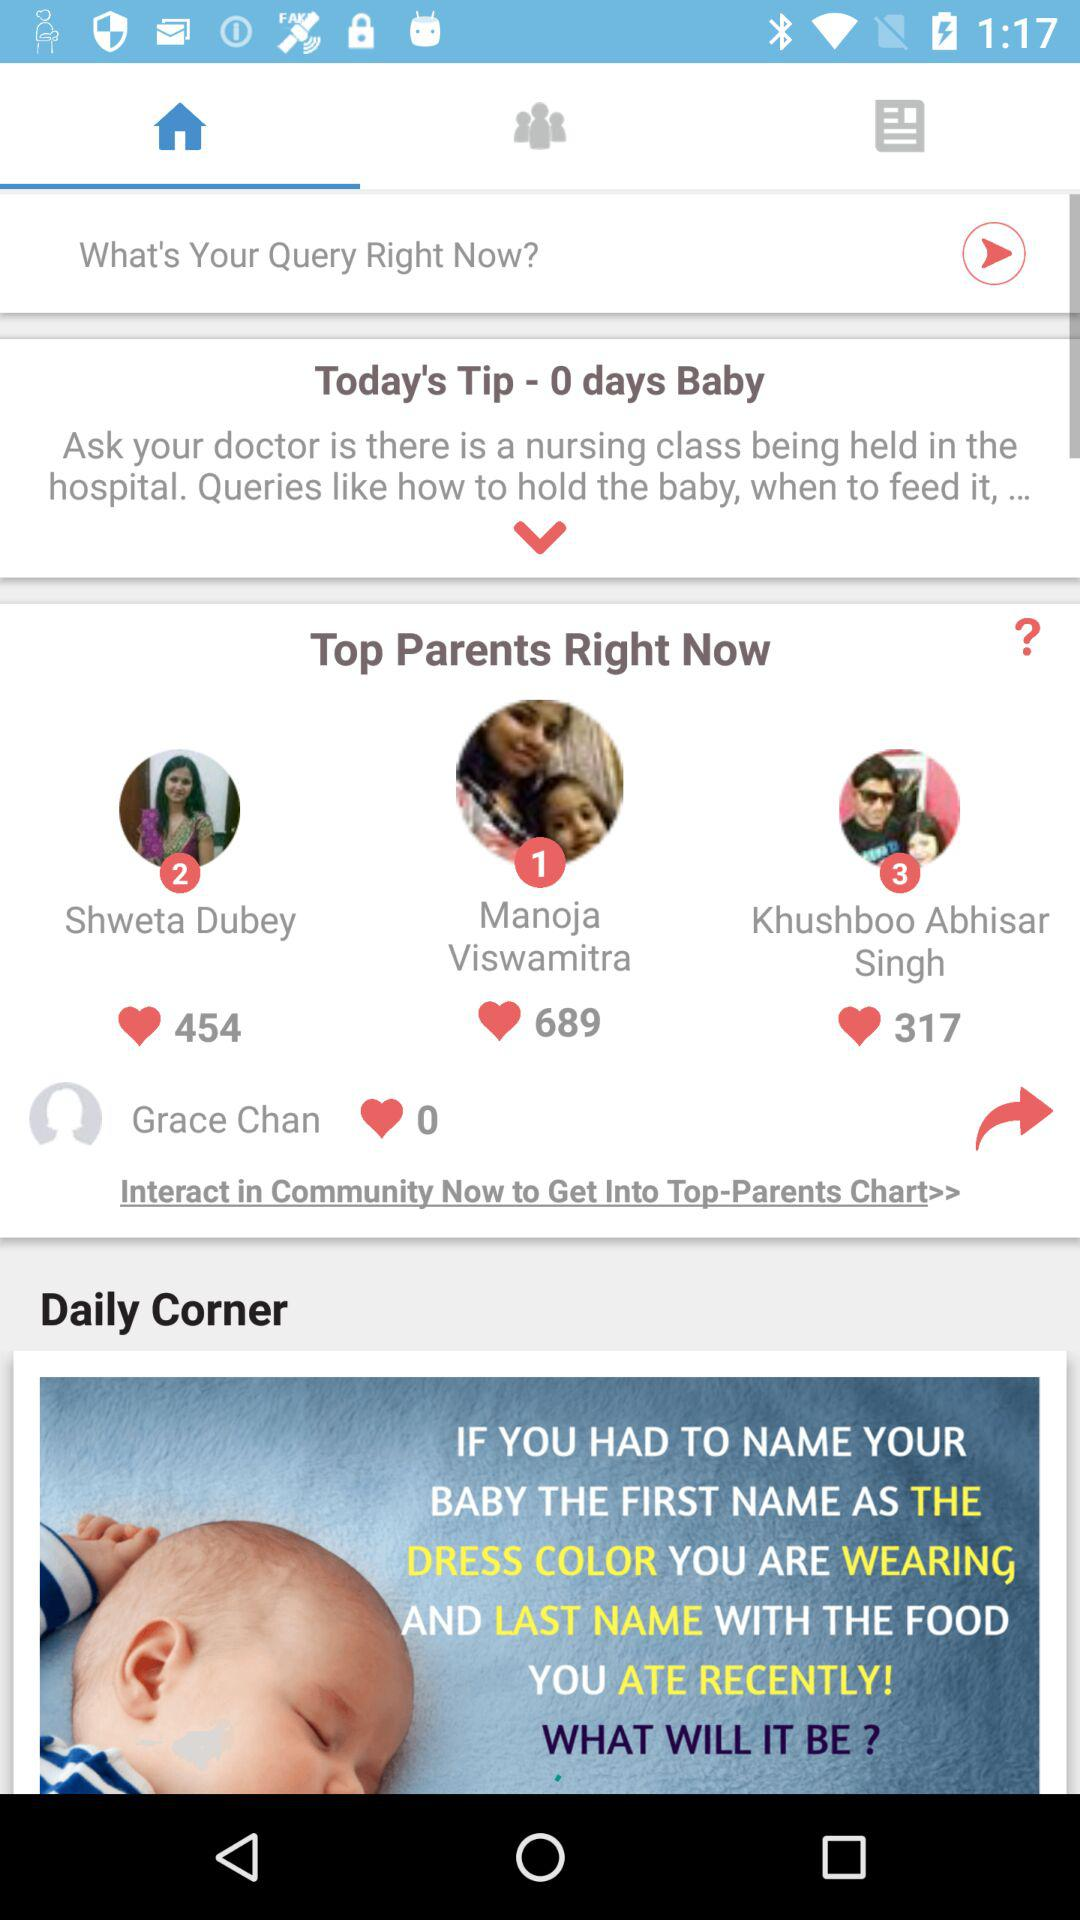Who got the first rank? The person who got the first rank is Manoja Viswamitra. 